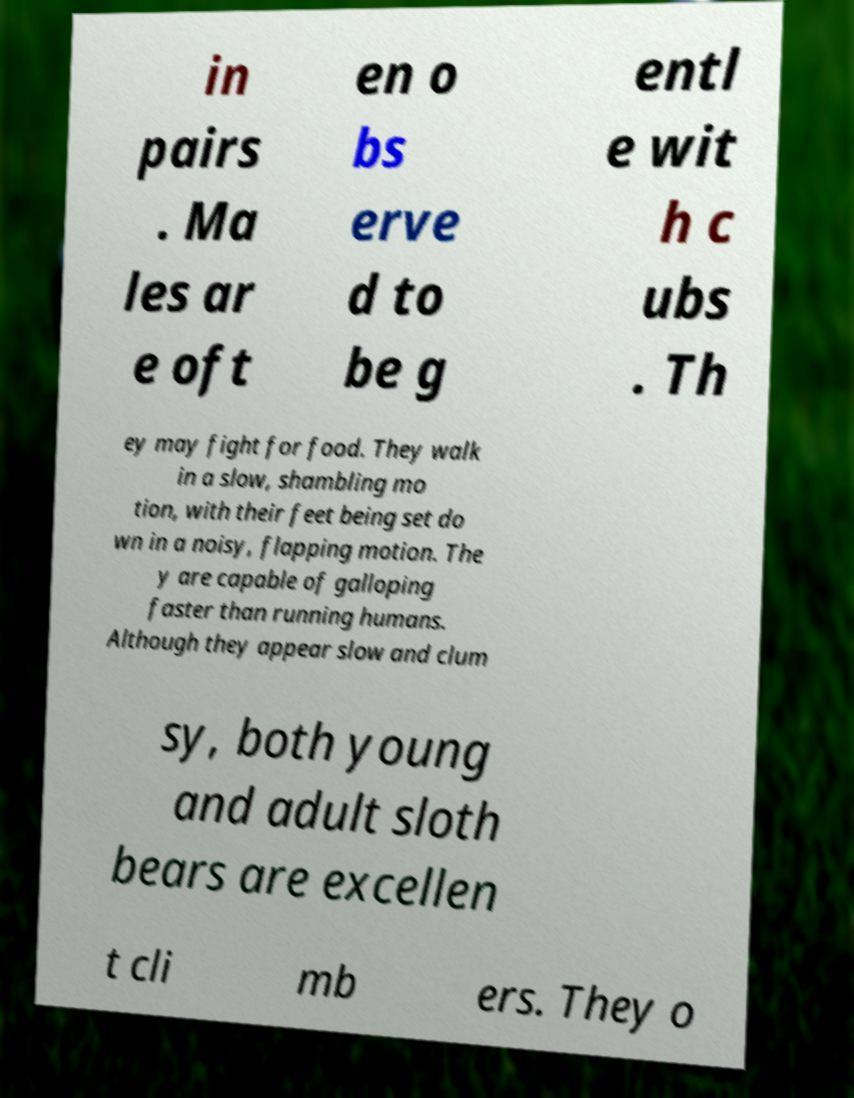Could you assist in decoding the text presented in this image and type it out clearly? in pairs . Ma les ar e oft en o bs erve d to be g entl e wit h c ubs . Th ey may fight for food. They walk in a slow, shambling mo tion, with their feet being set do wn in a noisy, flapping motion. The y are capable of galloping faster than running humans. Although they appear slow and clum sy, both young and adult sloth bears are excellen t cli mb ers. They o 